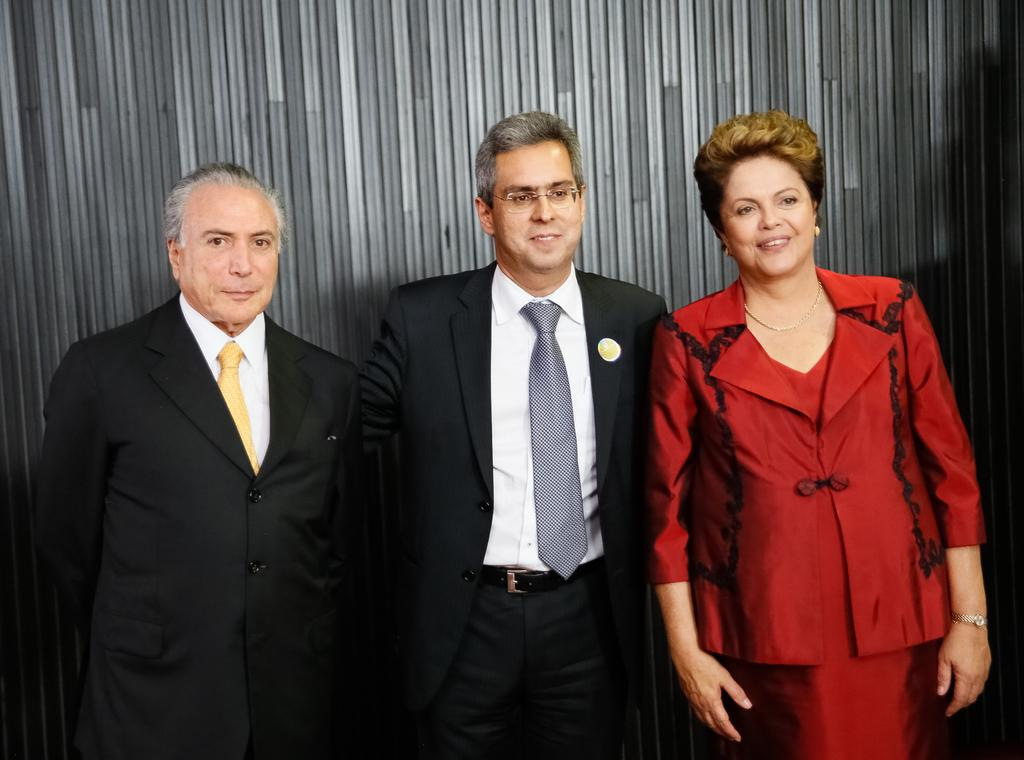How many people are in the foreground of the image? There are three people in the foreground of the image, including two men and one woman. What can be seen in the background of the image? There are pole-like objects in the background of the image. What type of chain can be seen connecting the two men in the image? There is no chain connecting the two men in the image; they are standing separately. 